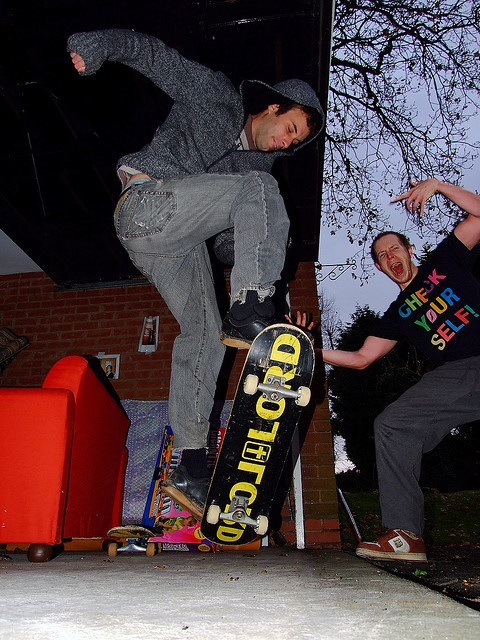Describe the objects in this image and their specific colors. I can see people in black, gray, and brown tones, people in black, brown, maroon, and gray tones, couch in black, red, and maroon tones, skateboard in black, gray, khaki, and darkgray tones, and people in black, gray, and purple tones in this image. 